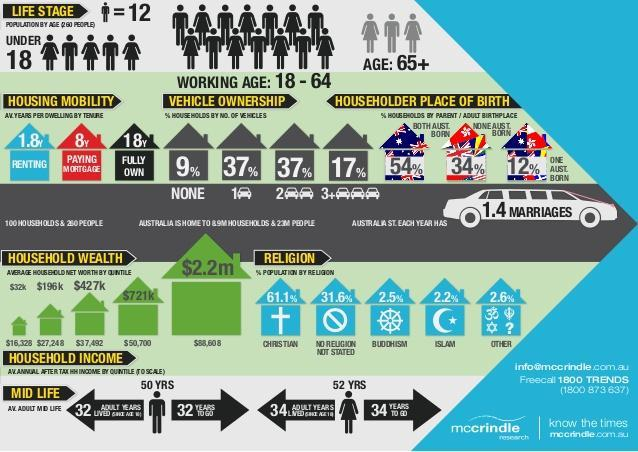What is the average adult mid life age for female?
Answer the question with a short phrase. 52 What is the average years per dwelling by tenure for a fully owned house? 18 Which religion has the second lowest percentage population? Buddhism What percentage of households own 1 vehicle? 37% What is the average adult mid life age for male? 50 yrs What is the total percentage of population who do not follow Christianity? 38.9 What percentage of population have both Australian born parents? 54 What percentage of households own 3 or more vehicles? 17% What is the total percentage of households who own one or more vehicles? 91 